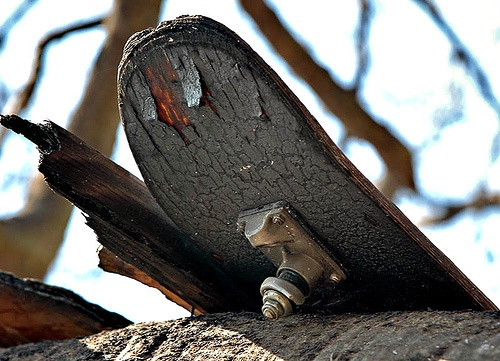Describe the objects in this image and their specific colors. I can see snowboard in white, black, gray, and maroon tones and skateboard in white, black, gray, and maroon tones in this image. 